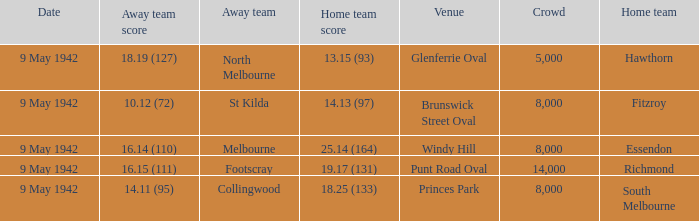How many people attended the game with the home team scoring 18.25 (133)? 1.0. 